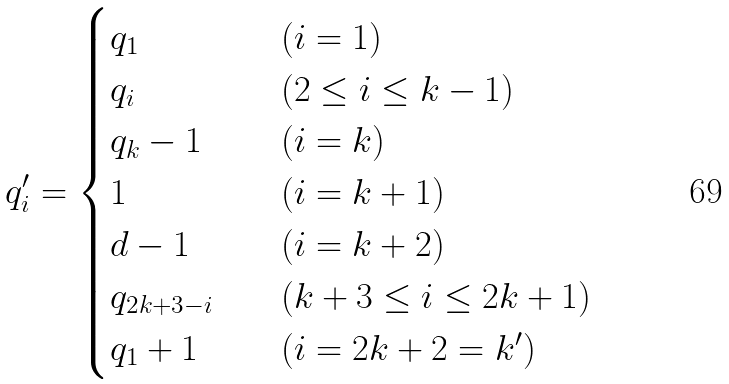Convert formula to latex. <formula><loc_0><loc_0><loc_500><loc_500>q ^ { \prime } _ { i } = \begin{cases} q _ { 1 } \quad & ( i = 1 ) \\ q _ { i } \quad & ( 2 \leq i \leq k - 1 ) \\ q _ { k } - 1 \quad & ( i = k ) \\ 1 \quad & ( i = k + 1 ) \\ d - 1 \quad & ( i = k + 2 ) \\ q _ { 2 k + 3 - i } \quad & ( k + 3 \leq i \leq 2 k + 1 ) \\ q _ { 1 } + 1 \quad & ( i = 2 k + 2 = k ^ { \prime } ) \end{cases}</formula> 